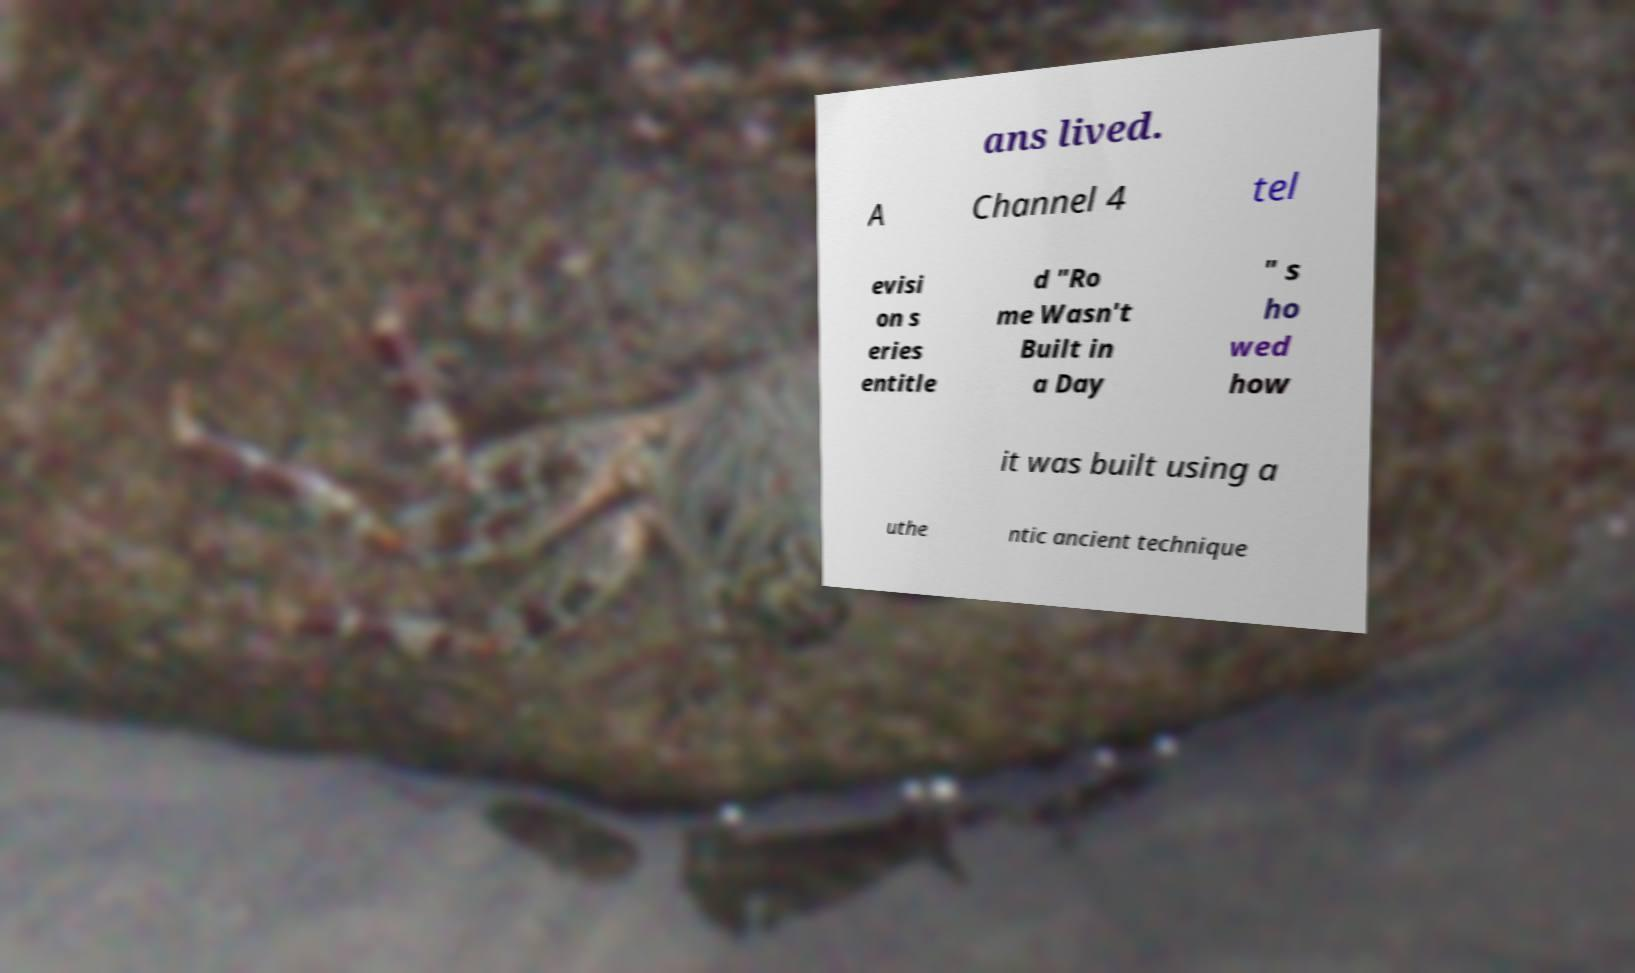Please identify and transcribe the text found in this image. ans lived. A Channel 4 tel evisi on s eries entitle d "Ro me Wasn't Built in a Day " s ho wed how it was built using a uthe ntic ancient technique 